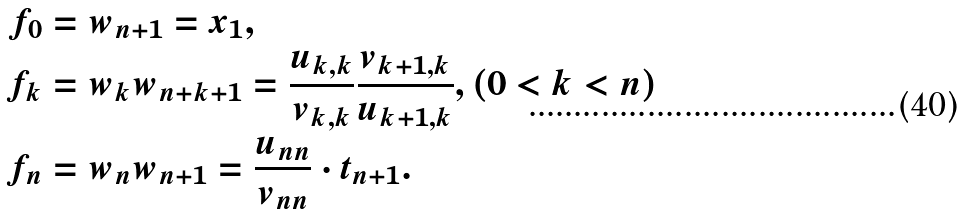<formula> <loc_0><loc_0><loc_500><loc_500>f _ { 0 } & = w _ { n + 1 } = x _ { 1 } , \\ f _ { k } & = w _ { k } w _ { n + k + 1 } = \frac { u _ { k , k } } { v _ { k , k } } \frac { v _ { k + 1 , k } } { u _ { k + 1 , k } } , ( 0 < k < n ) \\ f _ { n } & = w _ { n } w _ { n + 1 } = \frac { u _ { n n } } { v _ { n n } } \cdot t _ { n + 1 } .</formula> 